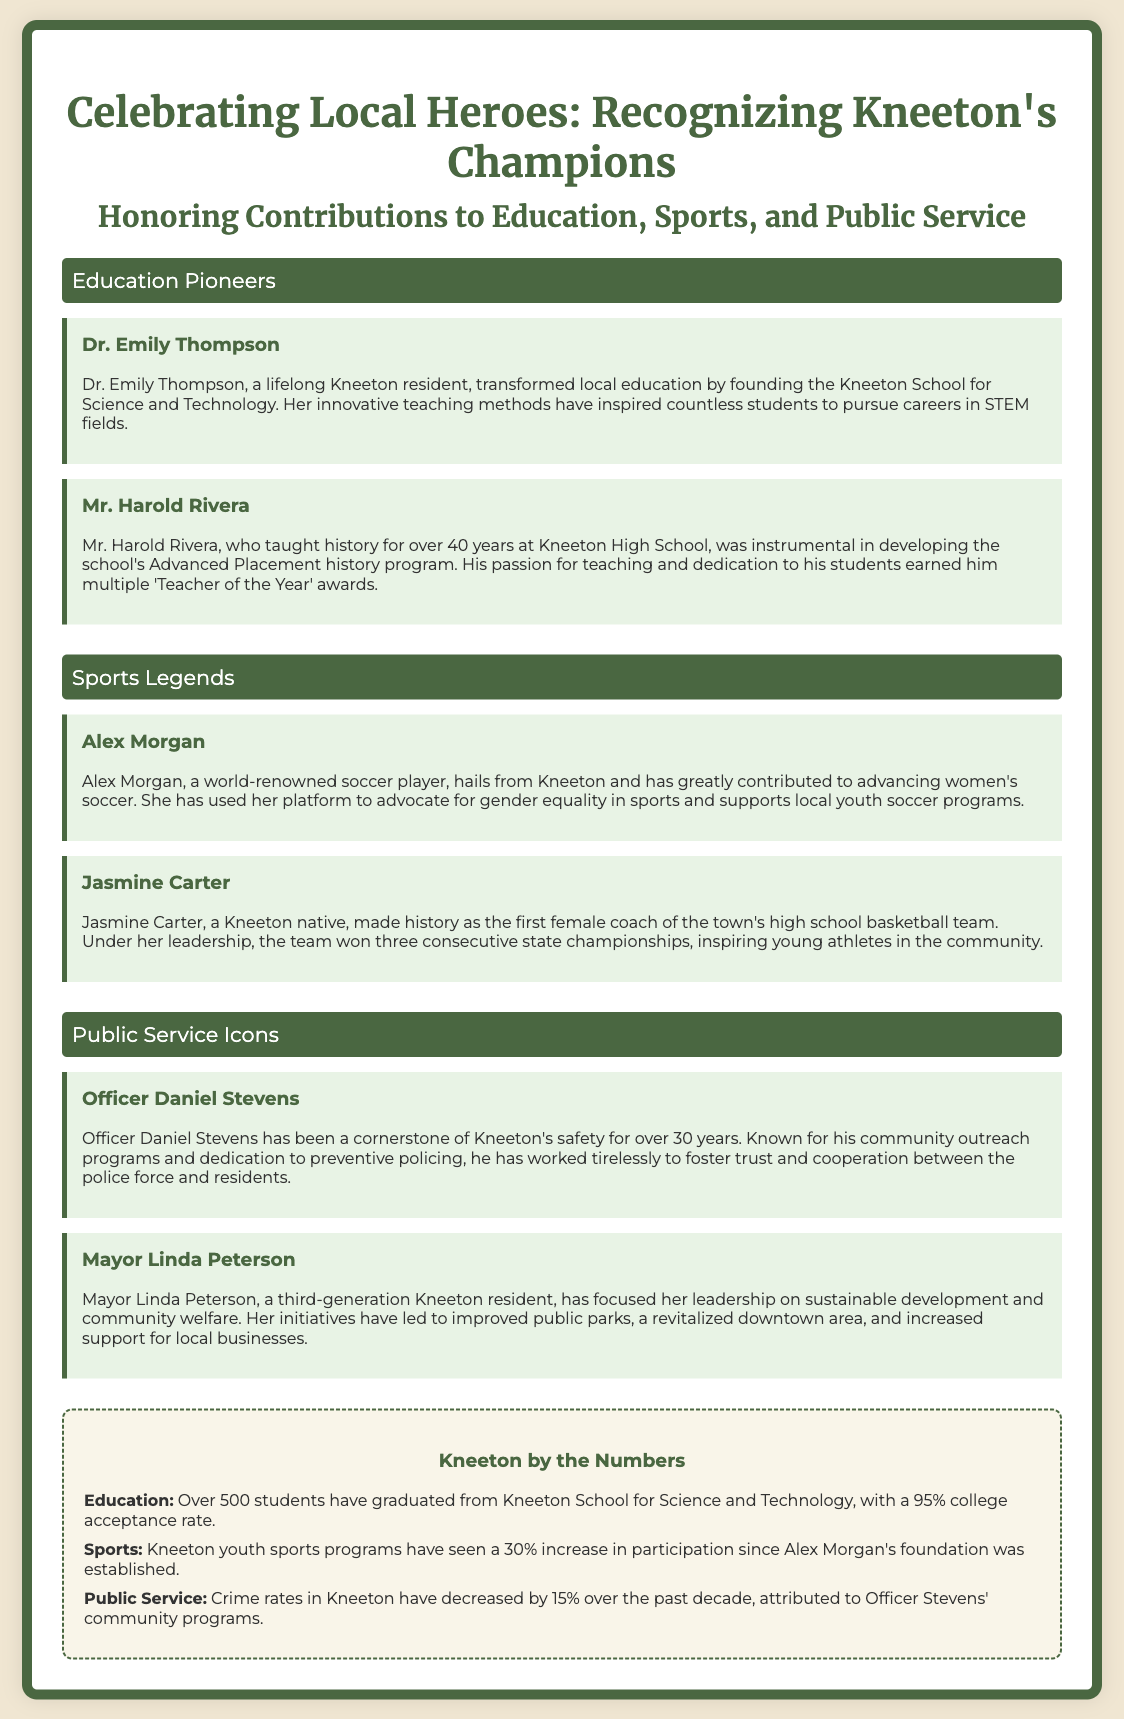What is the name of the school founded by Dr. Emily Thompson? The name of the school founded by Dr. Emily Thompson is the Kneeton School for Science and Technology.
Answer: Kneeton School for Science and Technology How many years did Mr. Harold Rivera teach history? Mr. Harold Rivera taught history for over 40 years.
Answer: over 40 years What sport is Alex Morgan associated with? Alex Morgan is associated with soccer.
Answer: soccer How many consecutive state championships did Jasmine Carter's team win? Jasmine Carter's team won three consecutive state championships.
Answer: three What percentage of students graduated from the Kneeton School for Science and Technology? The percentage of students who graduated is 95%.
Answer: 95% What has Officer Daniel Stevens focused on for Kneeton's safety? Officer Daniel Stevens has focused on community outreach programs and preventive policing.
Answer: community outreach programs and preventive policing What is Mayor Linda Peterson known for in her leadership? Mayor Linda Peterson is known for sustainable development and community welfare.
Answer: sustainable development and community welfare By what percentage have youth sports program participations increased? Participation in youth sports programs has increased by 30%.
Answer: 30% What is the local crime rate decrease attributed to? The crime rate decrease is attributed to Officer Stevens' community programs.
Answer: Officer Stevens' community programs 